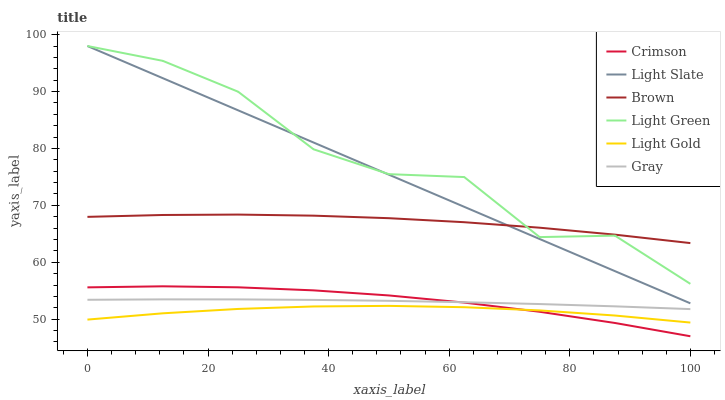Does Light Gold have the minimum area under the curve?
Answer yes or no. Yes. Does Light Green have the maximum area under the curve?
Answer yes or no. Yes. Does Brown have the minimum area under the curve?
Answer yes or no. No. Does Brown have the maximum area under the curve?
Answer yes or no. No. Is Light Slate the smoothest?
Answer yes or no. Yes. Is Light Green the roughest?
Answer yes or no. Yes. Is Brown the smoothest?
Answer yes or no. No. Is Brown the roughest?
Answer yes or no. No. Does Crimson have the lowest value?
Answer yes or no. Yes. Does Light Slate have the lowest value?
Answer yes or no. No. Does Light Green have the highest value?
Answer yes or no. Yes. Does Brown have the highest value?
Answer yes or no. No. Is Gray less than Light Green?
Answer yes or no. Yes. Is Brown greater than Crimson?
Answer yes or no. Yes. Does Brown intersect Light Green?
Answer yes or no. Yes. Is Brown less than Light Green?
Answer yes or no. No. Is Brown greater than Light Green?
Answer yes or no. No. Does Gray intersect Light Green?
Answer yes or no. No. 